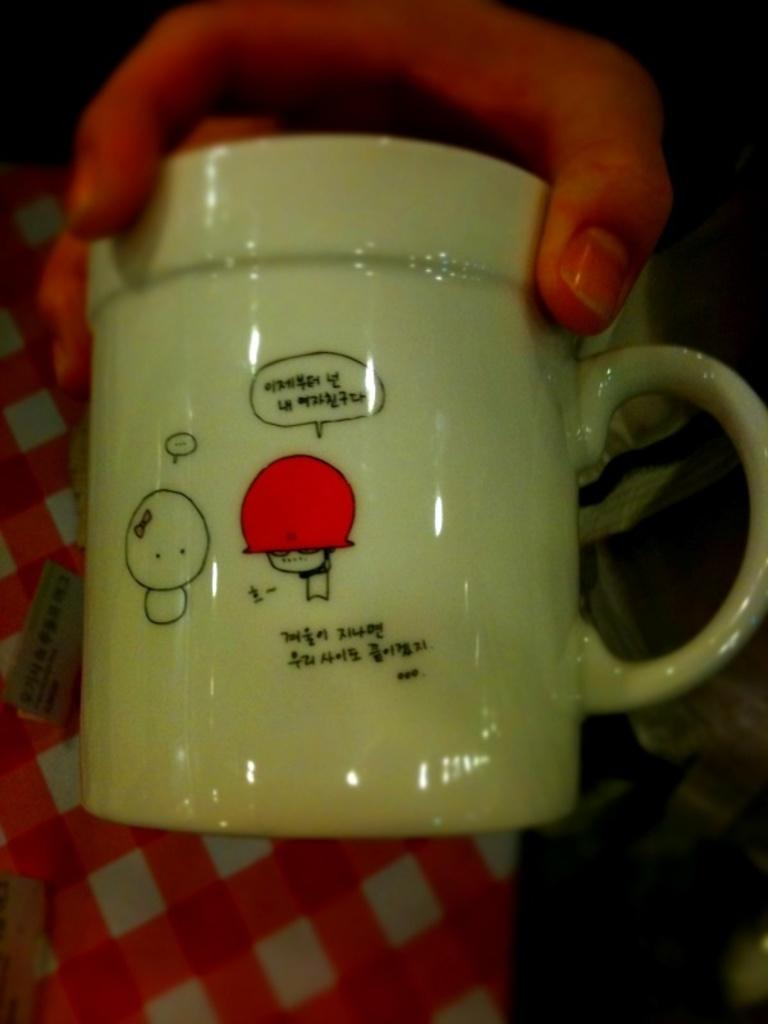What is the main subject of the image? The main subject of the image is the hand of a person. What is the hand holding? The hand is holding a white color cup. Can you describe the cup? The cup has paintings and texts on it. What is the color of the background in the image? The background of the image is dark in color. Where is the owner of the hand sitting in the image? The image does not show the owner of the hand or any furniture, so it cannot be determined where they might be sitting. 